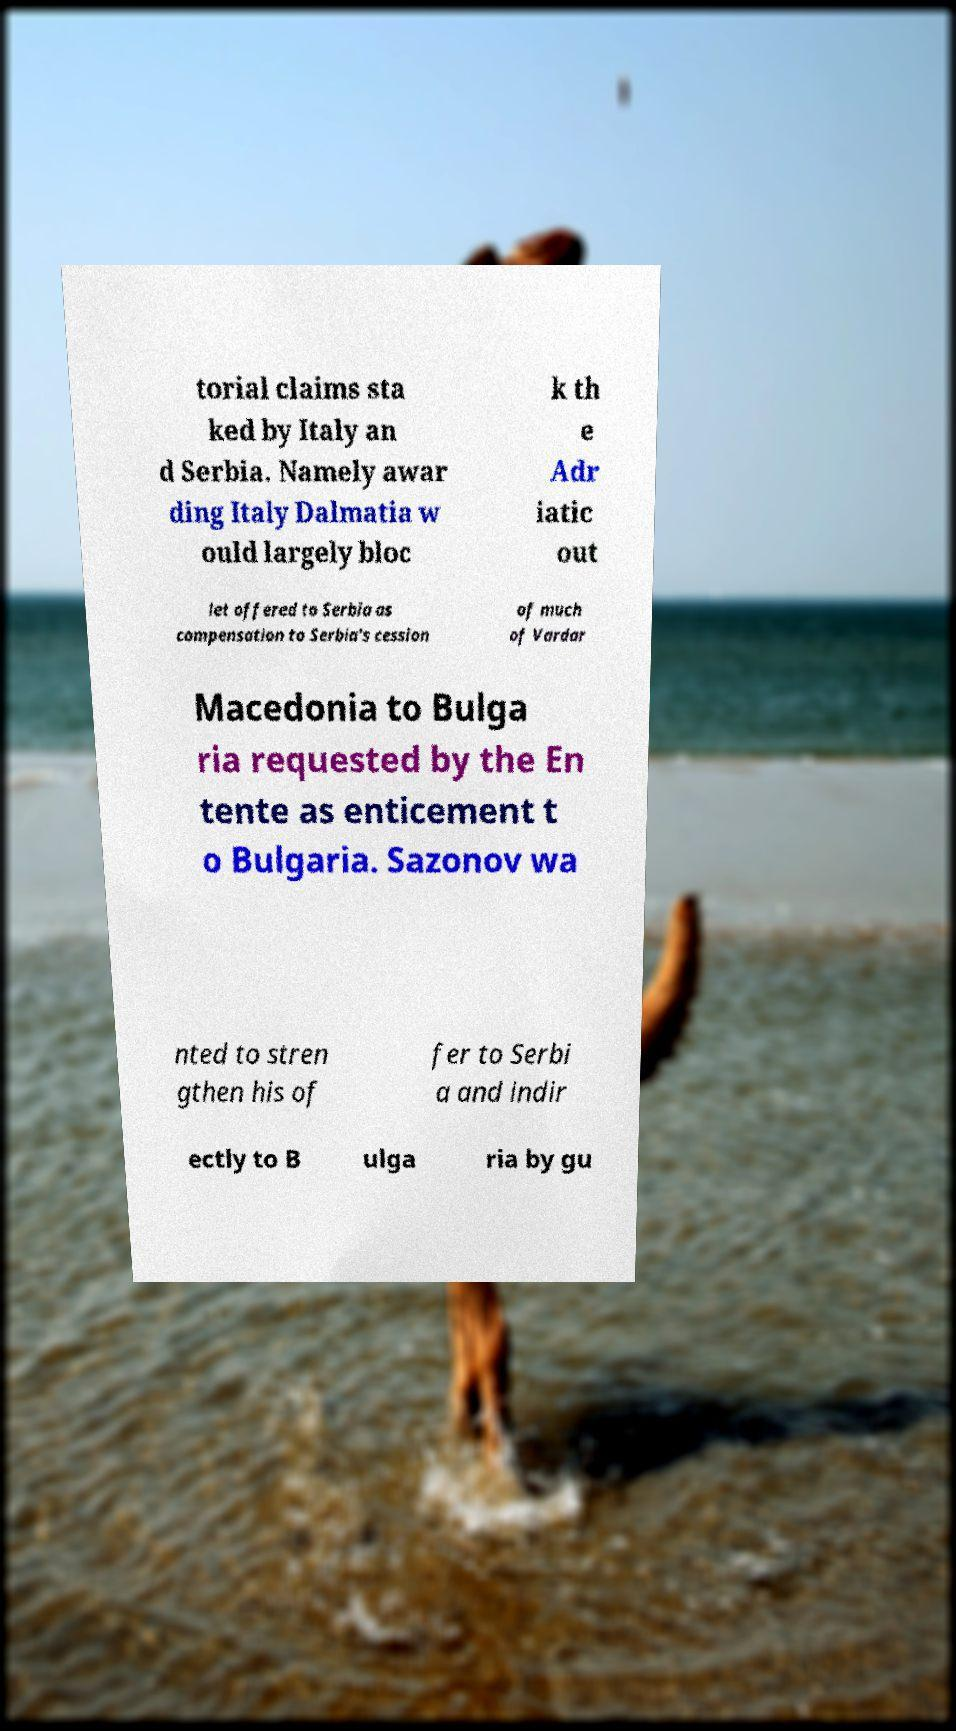Can you accurately transcribe the text from the provided image for me? torial claims sta ked by Italy an d Serbia. Namely awar ding Italy Dalmatia w ould largely bloc k th e Adr iatic out let offered to Serbia as compensation to Serbia's cession of much of Vardar Macedonia to Bulga ria requested by the En tente as enticement t o Bulgaria. Sazonov wa nted to stren gthen his of fer to Serbi a and indir ectly to B ulga ria by gu 